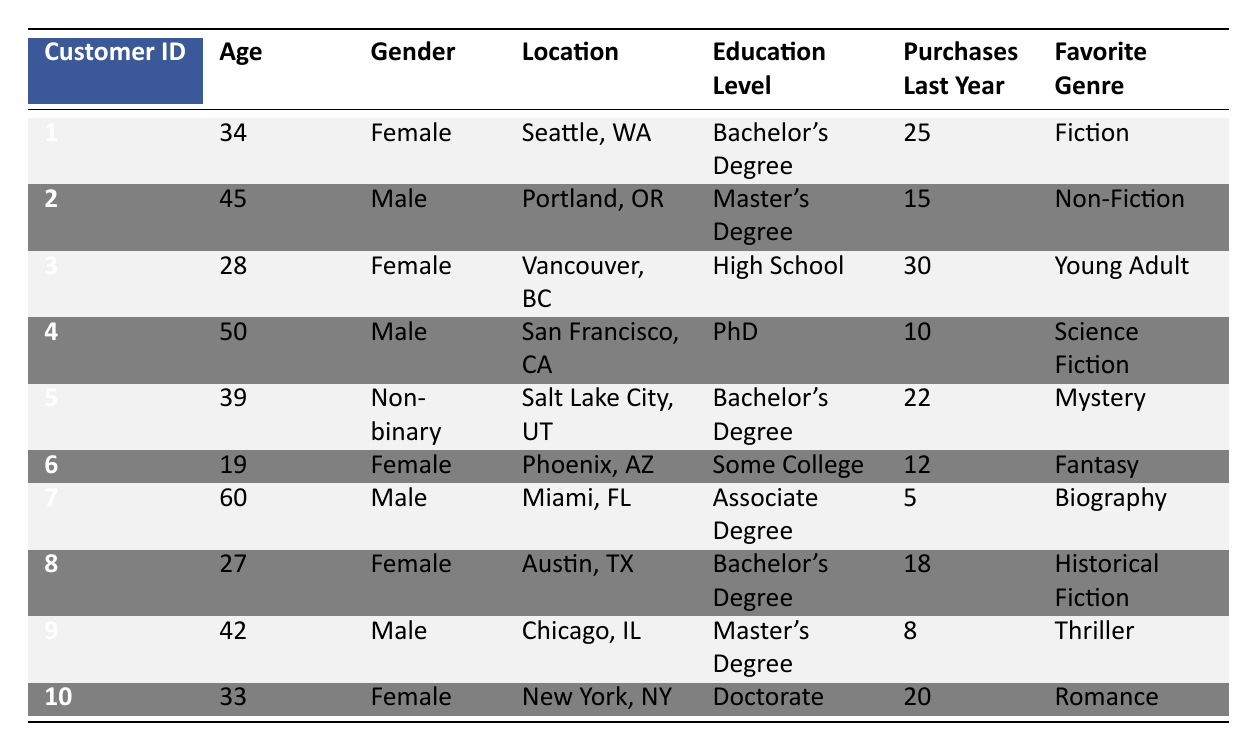What is the favorite genre of the customer from Seattle, WA? The customer from Seattle, WA has a Customer ID of 1. Looking at the table, the Favorite Genre for this customer is Fiction.
Answer: Fiction How many purchases did the 60-year-old customer make last year? The 60-year-old customer has a Customer ID of 7. According to the table, this customer made 5 purchases last year.
Answer: 5 What is the average age of customers who purchased more than 20 books last year? To find the average age of customers who purchased more than 20 books, I will first identify them: Customer IDs 1 (34 years old), 3 (28 years old), and 5 (39 years old). Next, I sum their ages: 34 + 28 + 39 = 101. Since there are 3 customers, the average age is 101/3 = 33.67.
Answer: 33.67 Did any of the customers with a Master's Degree purchase more than 15 books last year? The customers with a Master's Degree are Customer IDs 2 (15 purchases) and 9 (8 purchases). Neither of these customers made more than 15 purchases, so the answer is no.
Answer: No What is the total number of purchases made by female customers last year? The female customers are Customer IDs 1 (25 purchases), 3 (30 purchases), 6 (12 purchases), 8 (18 purchases), and 10 (20 purchases). Adding these together: 25 + 30 + 12 + 18 + 20 = 115.
Answer: 115 